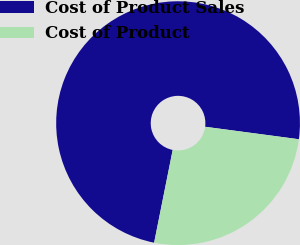Convert chart to OTSL. <chart><loc_0><loc_0><loc_500><loc_500><pie_chart><fcel>Cost of Product Sales<fcel>Cost of Product<nl><fcel>73.96%<fcel>26.04%<nl></chart> 